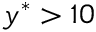<formula> <loc_0><loc_0><loc_500><loc_500>y ^ { * } > 1 0</formula> 